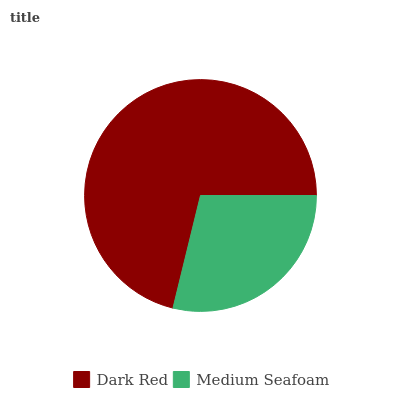Is Medium Seafoam the minimum?
Answer yes or no. Yes. Is Dark Red the maximum?
Answer yes or no. Yes. Is Medium Seafoam the maximum?
Answer yes or no. No. Is Dark Red greater than Medium Seafoam?
Answer yes or no. Yes. Is Medium Seafoam less than Dark Red?
Answer yes or no. Yes. Is Medium Seafoam greater than Dark Red?
Answer yes or no. No. Is Dark Red less than Medium Seafoam?
Answer yes or no. No. Is Dark Red the high median?
Answer yes or no. Yes. Is Medium Seafoam the low median?
Answer yes or no. Yes. Is Medium Seafoam the high median?
Answer yes or no. No. Is Dark Red the low median?
Answer yes or no. No. 